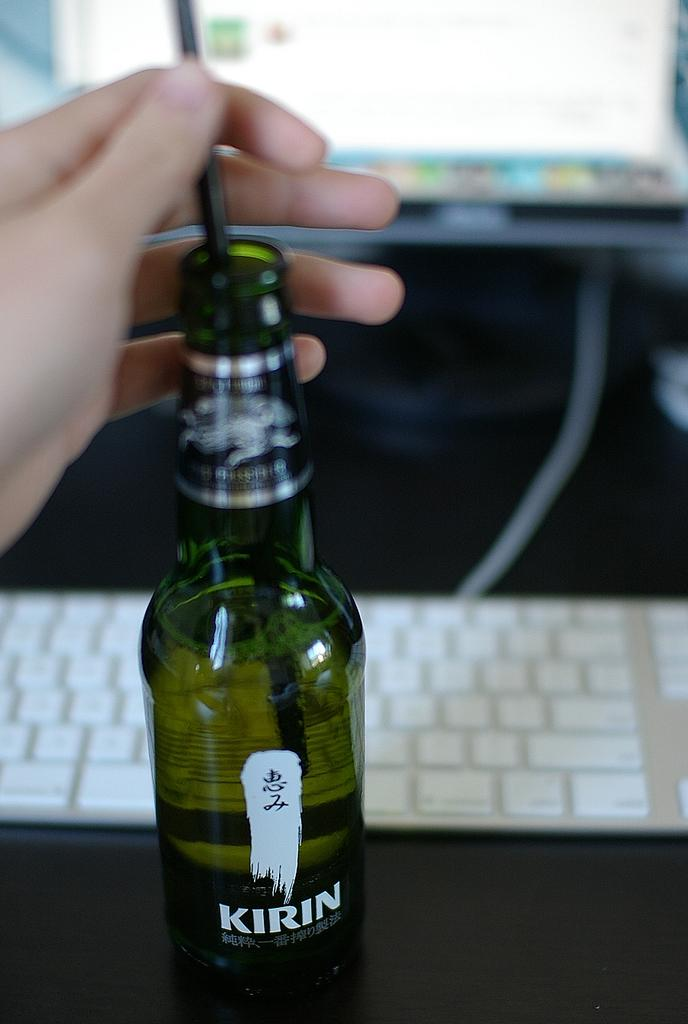Provide a one-sentence caption for the provided image. A bottle of a drink called kirin next to a keyboard. 